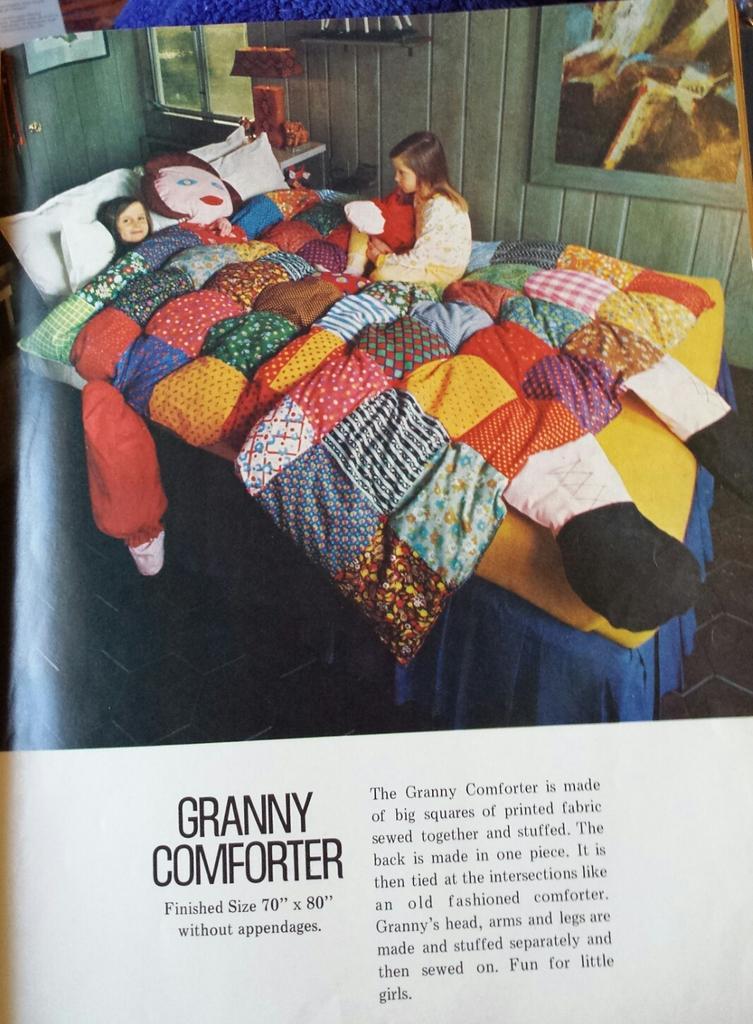In one or two sentences, can you explain what this image depicts? In this image we can see a picture of two children. One girl lying on the bed and a doll is placed on the bed. In the background, we can see photo frames on the wall, a lamp placed on the table and window. At the bottom of the image we can see some text 